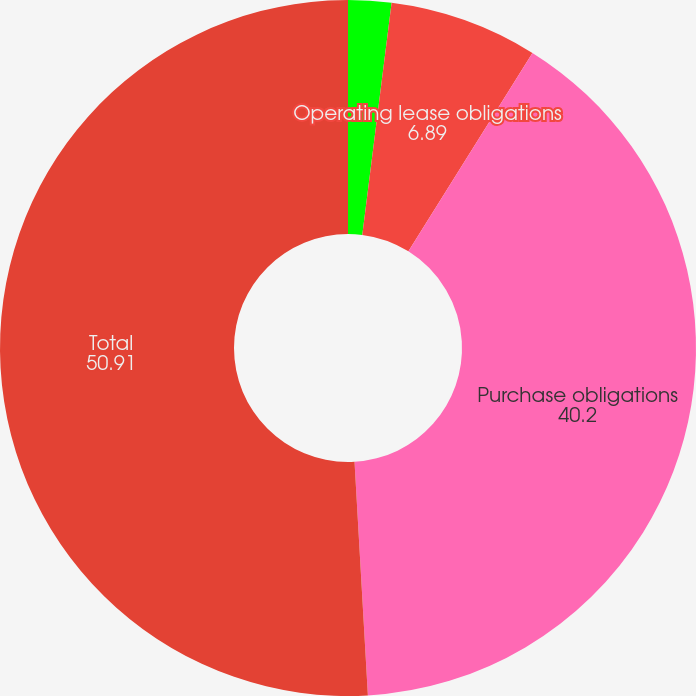Convert chart. <chart><loc_0><loc_0><loc_500><loc_500><pie_chart><fcel>Debt and capital lease<fcel>Operating lease obligations<fcel>Purchase obligations<fcel>Total<nl><fcel>2.0%<fcel>6.89%<fcel>40.2%<fcel>50.91%<nl></chart> 